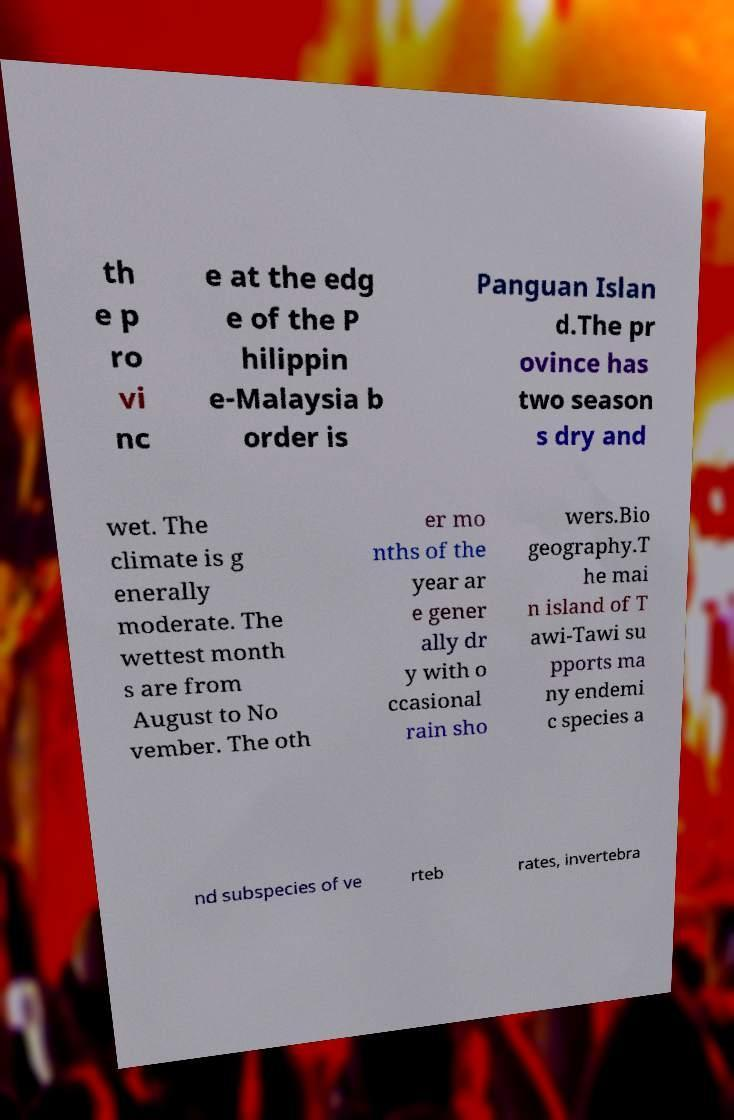Could you extract and type out the text from this image? th e p ro vi nc e at the edg e of the P hilippin e-Malaysia b order is Panguan Islan d.The pr ovince has two season s dry and wet. The climate is g enerally moderate. The wettest month s are from August to No vember. The oth er mo nths of the year ar e gener ally dr y with o ccasional rain sho wers.Bio geography.T he mai n island of T awi-Tawi su pports ma ny endemi c species a nd subspecies of ve rteb rates, invertebra 